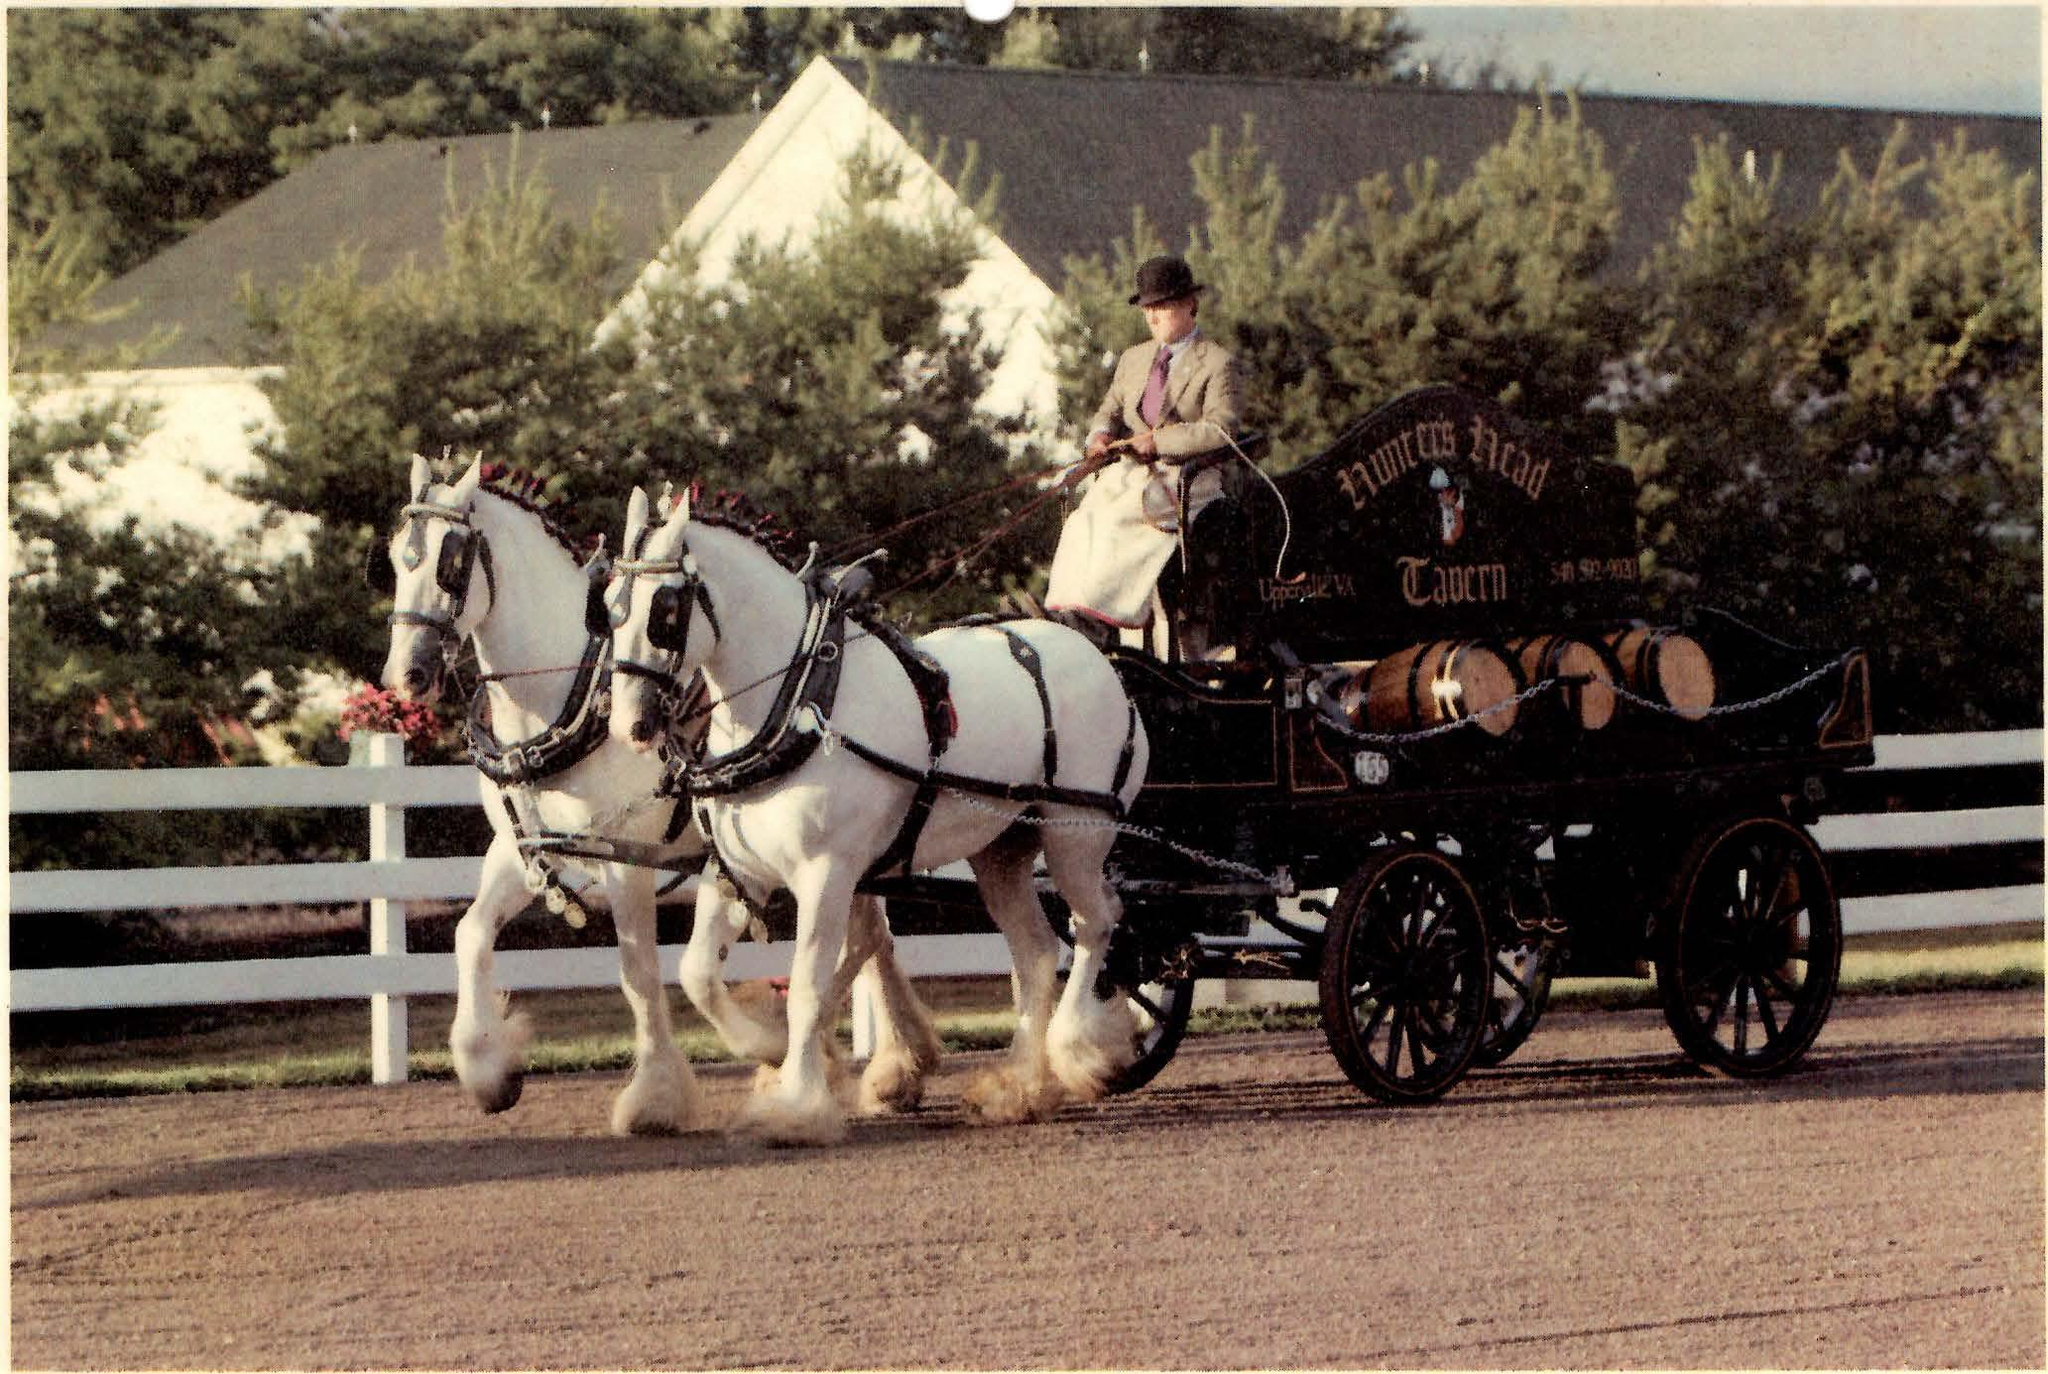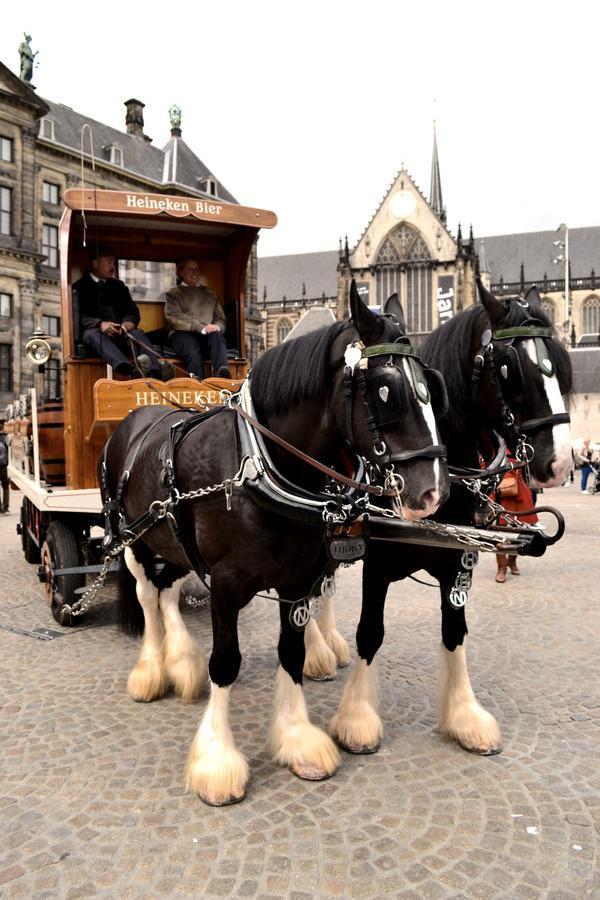The first image is the image on the left, the second image is the image on the right. Assess this claim about the two images: "An image shows a wagon carrying at least one wooden barrel.". Correct or not? Answer yes or no. Yes. 